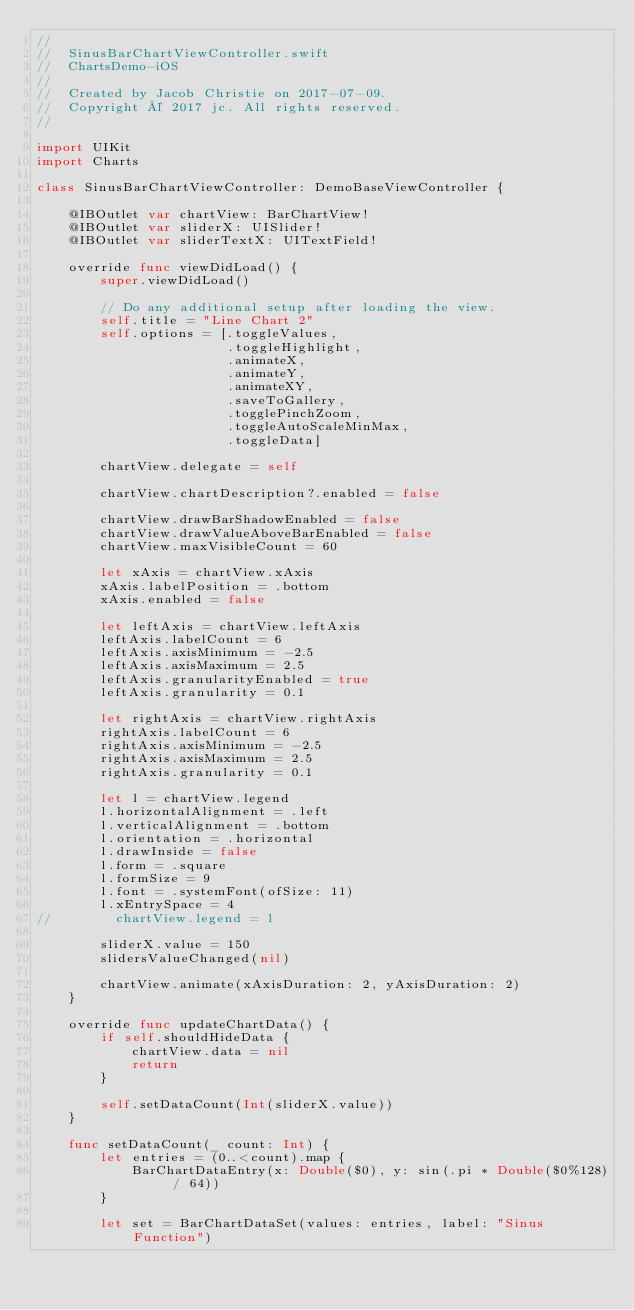Convert code to text. <code><loc_0><loc_0><loc_500><loc_500><_Swift_>//
//  SinusBarChartViewController.swift
//  ChartsDemo-iOS
//
//  Created by Jacob Christie on 2017-07-09.
//  Copyright © 2017 jc. All rights reserved.
//

import UIKit
import Charts

class SinusBarChartViewController: DemoBaseViewController {
    
    @IBOutlet var chartView: BarChartView!
    @IBOutlet var sliderX: UISlider!
    @IBOutlet var sliderTextX: UITextField!
    
    override func viewDidLoad() {
        super.viewDidLoad()
        
        // Do any additional setup after loading the view.
        self.title = "Line Chart 2"
        self.options = [.toggleValues,
                        .toggleHighlight,
                        .animateX,
                        .animateY,
                        .animateXY,
                        .saveToGallery,
                        .togglePinchZoom,
                        .toggleAutoScaleMinMax,
                        .toggleData]
        
        chartView.delegate = self
        
        chartView.chartDescription?.enabled = false
        
        chartView.drawBarShadowEnabled = false
        chartView.drawValueAboveBarEnabled = false
        chartView.maxVisibleCount = 60
        
        let xAxis = chartView.xAxis
        xAxis.labelPosition = .bottom
        xAxis.enabled = false
        
        let leftAxis = chartView.leftAxis
        leftAxis.labelCount = 6
        leftAxis.axisMinimum = -2.5
        leftAxis.axisMaximum = 2.5
        leftAxis.granularityEnabled = true
        leftAxis.granularity = 0.1
        
        let rightAxis = chartView.rightAxis
        rightAxis.labelCount = 6
        rightAxis.axisMinimum = -2.5
        rightAxis.axisMaximum = 2.5
        rightAxis.granularity = 0.1

        let l = chartView.legend
        l.horizontalAlignment = .left
        l.verticalAlignment = .bottom
        l.orientation = .horizontal
        l.drawInside = false
        l.form = .square
        l.formSize = 9
        l.font = .systemFont(ofSize: 11)
        l.xEntrySpace = 4
//        chartView.legend = l

        sliderX.value = 150
        slidersValueChanged(nil)
        
        chartView.animate(xAxisDuration: 2, yAxisDuration: 2)
    }
    
    override func updateChartData() {
        if self.shouldHideData {
            chartView.data = nil
            return
        }
        
        self.setDataCount(Int(sliderX.value))
    }
    
    func setDataCount(_ count: Int) {
        let entries = (0..<count).map {
            BarChartDataEntry(x: Double($0), y: sin(.pi * Double($0%128) / 64))
        }
        
        let set = BarChartDataSet(values: entries, label: "Sinus Function")</code> 